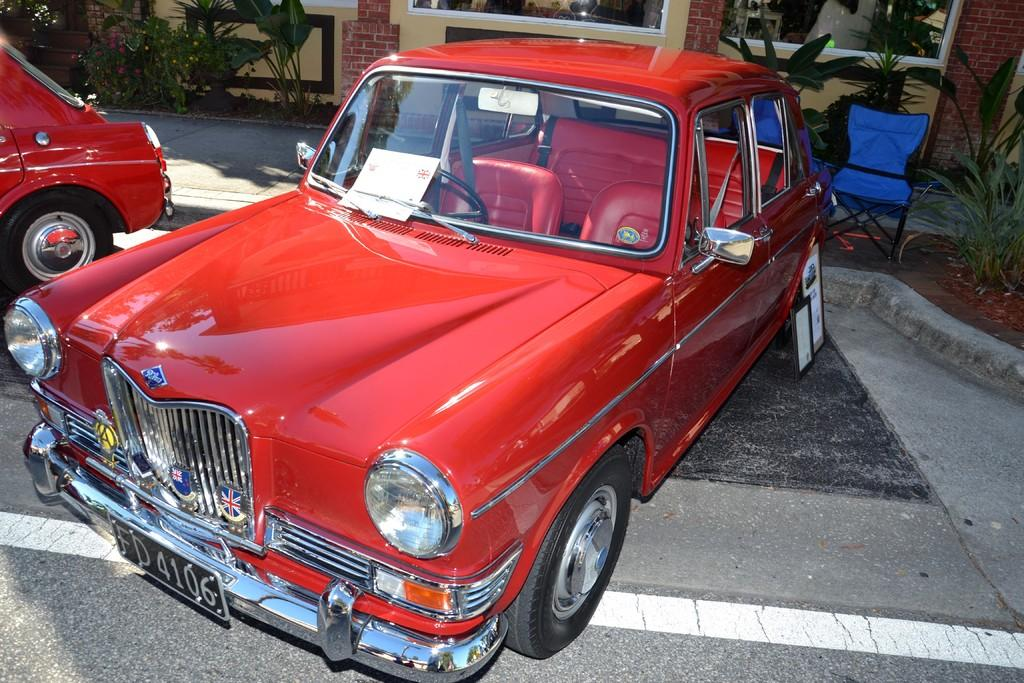What can be seen on the road in the image? There are cars on the road in the image. What type of vegetation is visible in the image? There are plants visible in the image. What is located in the background of the image? There is a wall in the background of the image. What type of knife can be seen being used in the protest in the image? There is no protest or knife present in the image; it features cars on the road and plants. How many balls are visible in the image? There are no balls visible in the image. 